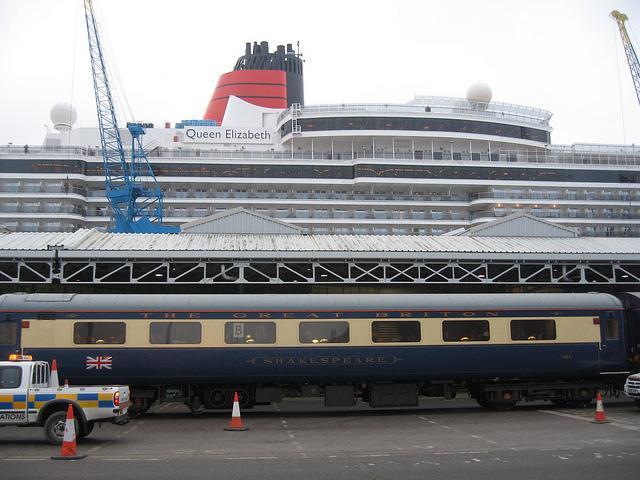How many trucks are there?
Give a very brief answer. 1. How many boats are there?
Give a very brief answer. 2. How many people are on the motorcycle?
Give a very brief answer. 0. 